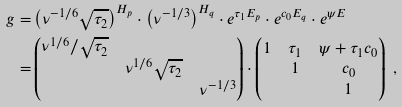Convert formula to latex. <formula><loc_0><loc_0><loc_500><loc_500>g = & \left ( { \nu ^ { - 1 / 6 } } \sqrt { \tau _ { 2 } } \right ) ^ { H _ { p } } \cdot \left ( \nu ^ { - 1 / 3 } \right ) ^ { H _ { q } } \cdot e ^ { \tau _ { 1 } E _ { p } } \cdot e ^ { c _ { 0 } E _ { q } } \cdot e ^ { \psi E } \\ = & \begin{pmatrix} { \nu ^ { 1 / 6 } } / \sqrt { \tau _ { 2 } } & & \\ & { \nu ^ { 1 / 6 } } \sqrt { \tau _ { 2 } } & \\ & & \nu ^ { - 1 / 3 } \end{pmatrix} \cdot \begin{pmatrix} 1 & \tau _ { 1 } & \psi + \tau _ { 1 } c _ { 0 } \\ & 1 & c _ { 0 } \\ & & 1 \end{pmatrix} \ ,</formula> 